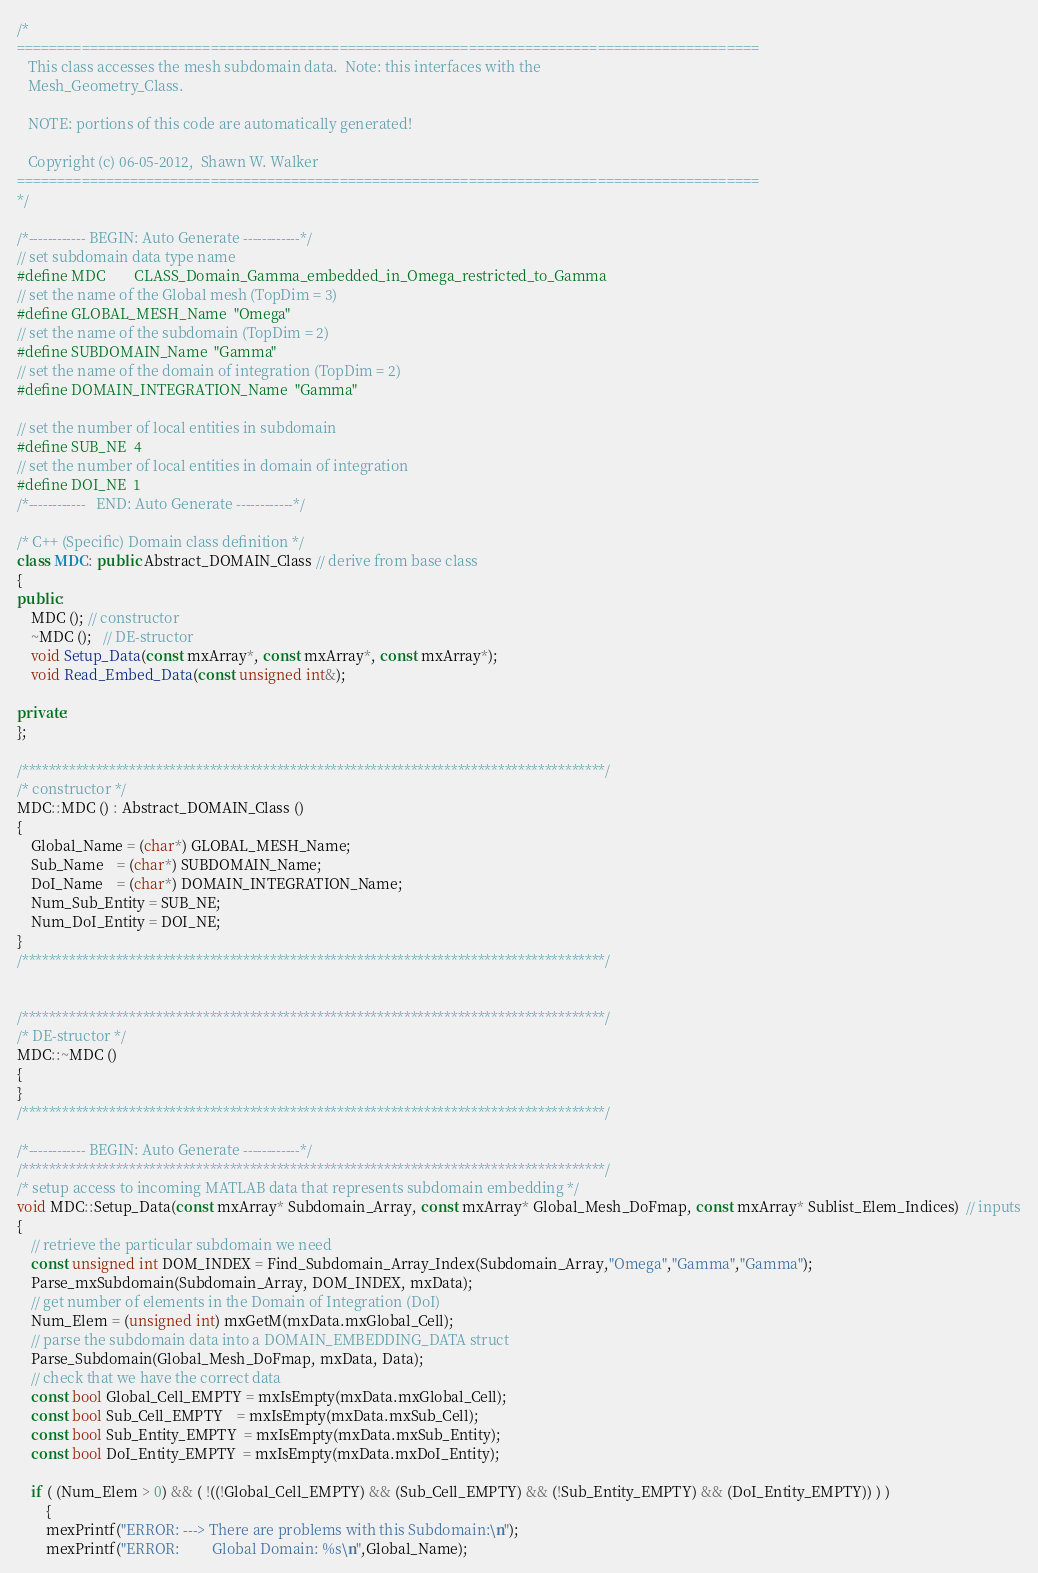Convert code to text. <code><loc_0><loc_0><loc_500><loc_500><_C++_>/*
============================================================================================
   This class accesses the mesh subdomain data.  Note: this interfaces with the
   Mesh_Geometry_Class.

   NOTE: portions of this code are automatically generated!

   Copyright (c) 06-05-2012,  Shawn W. Walker
============================================================================================
*/

/*------------ BEGIN: Auto Generate ------------*/
// set subdomain data type name
#define MDC        CLASS_Domain_Gamma_embedded_in_Omega_restricted_to_Gamma
// set the name of the Global mesh (TopDim = 3)
#define GLOBAL_MESH_Name  "Omega"
// set the name of the subdomain (TopDim = 2)
#define SUBDOMAIN_Name  "Gamma"
// set the name of the domain of integration (TopDim = 2)
#define DOMAIN_INTEGRATION_Name  "Gamma"

// set the number of local entities in subdomain
#define SUB_NE  4
// set the number of local entities in domain of integration
#define DOI_NE  1
/*------------   END: Auto Generate ------------*/

/* C++ (Specific) Domain class definition */
class MDC: public Abstract_DOMAIN_Class // derive from base class
{
public:
    MDC (); // constructor
    ~MDC ();   // DE-structor
    void Setup_Data(const mxArray*, const mxArray*, const mxArray*);
	void Read_Embed_Data(const unsigned int&);

private:
};

/***************************************************************************************/
/* constructor */
MDC::MDC () : Abstract_DOMAIN_Class ()
{
    Global_Name = (char*) GLOBAL_MESH_Name;
    Sub_Name    = (char*) SUBDOMAIN_Name;
	DoI_Name    = (char*) DOMAIN_INTEGRATION_Name;
    Num_Sub_Entity = SUB_NE;
	Num_DoI_Entity = DOI_NE;
}
/***************************************************************************************/


/***************************************************************************************/
/* DE-structor */
MDC::~MDC ()
{
}
/***************************************************************************************/

/*------------ BEGIN: Auto Generate ------------*/
/***************************************************************************************/
/* setup access to incoming MATLAB data that represents subdomain embedding */
void MDC::Setup_Data(const mxArray* Subdomain_Array, const mxArray* Global_Mesh_DoFmap, const mxArray* Sublist_Elem_Indices)  // inputs
{
    // retrieve the particular subdomain we need
    const unsigned int DOM_INDEX = Find_Subdomain_Array_Index(Subdomain_Array,"Omega","Gamma","Gamma");
    Parse_mxSubdomain(Subdomain_Array, DOM_INDEX, mxData);
    // get number of elements in the Domain of Integration (DoI)
    Num_Elem = (unsigned int) mxGetM(mxData.mxGlobal_Cell);
    // parse the subdomain data into a DOMAIN_EMBEDDING_DATA struct
    Parse_Subdomain(Global_Mesh_DoFmap, mxData, Data);
    // check that we have the correct data
    const bool Global_Cell_EMPTY = mxIsEmpty(mxData.mxGlobal_Cell);
    const bool Sub_Cell_EMPTY    = mxIsEmpty(mxData.mxSub_Cell);
    const bool Sub_Entity_EMPTY  = mxIsEmpty(mxData.mxSub_Entity);
    const bool DoI_Entity_EMPTY  = mxIsEmpty(mxData.mxDoI_Entity);

    if ( (Num_Elem > 0) && ( !((!Global_Cell_EMPTY) && (Sub_Cell_EMPTY) && (!Sub_Entity_EMPTY) && (DoI_Entity_EMPTY)) ) )
        {
        mexPrintf("ERROR: ---> There are problems with this Subdomain:\n");
        mexPrintf("ERROR:         Global Domain: %s\n",Global_Name);</code> 